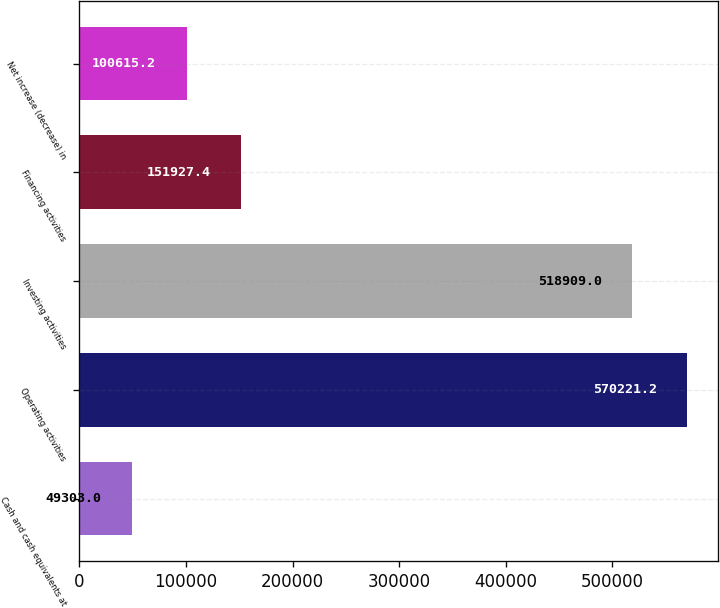Convert chart to OTSL. <chart><loc_0><loc_0><loc_500><loc_500><bar_chart><fcel>Cash and cash equivalents at<fcel>Operating activities<fcel>Investing activities<fcel>Financing activities<fcel>Net increase (decrease) in<nl><fcel>49303<fcel>570221<fcel>518909<fcel>151927<fcel>100615<nl></chart> 